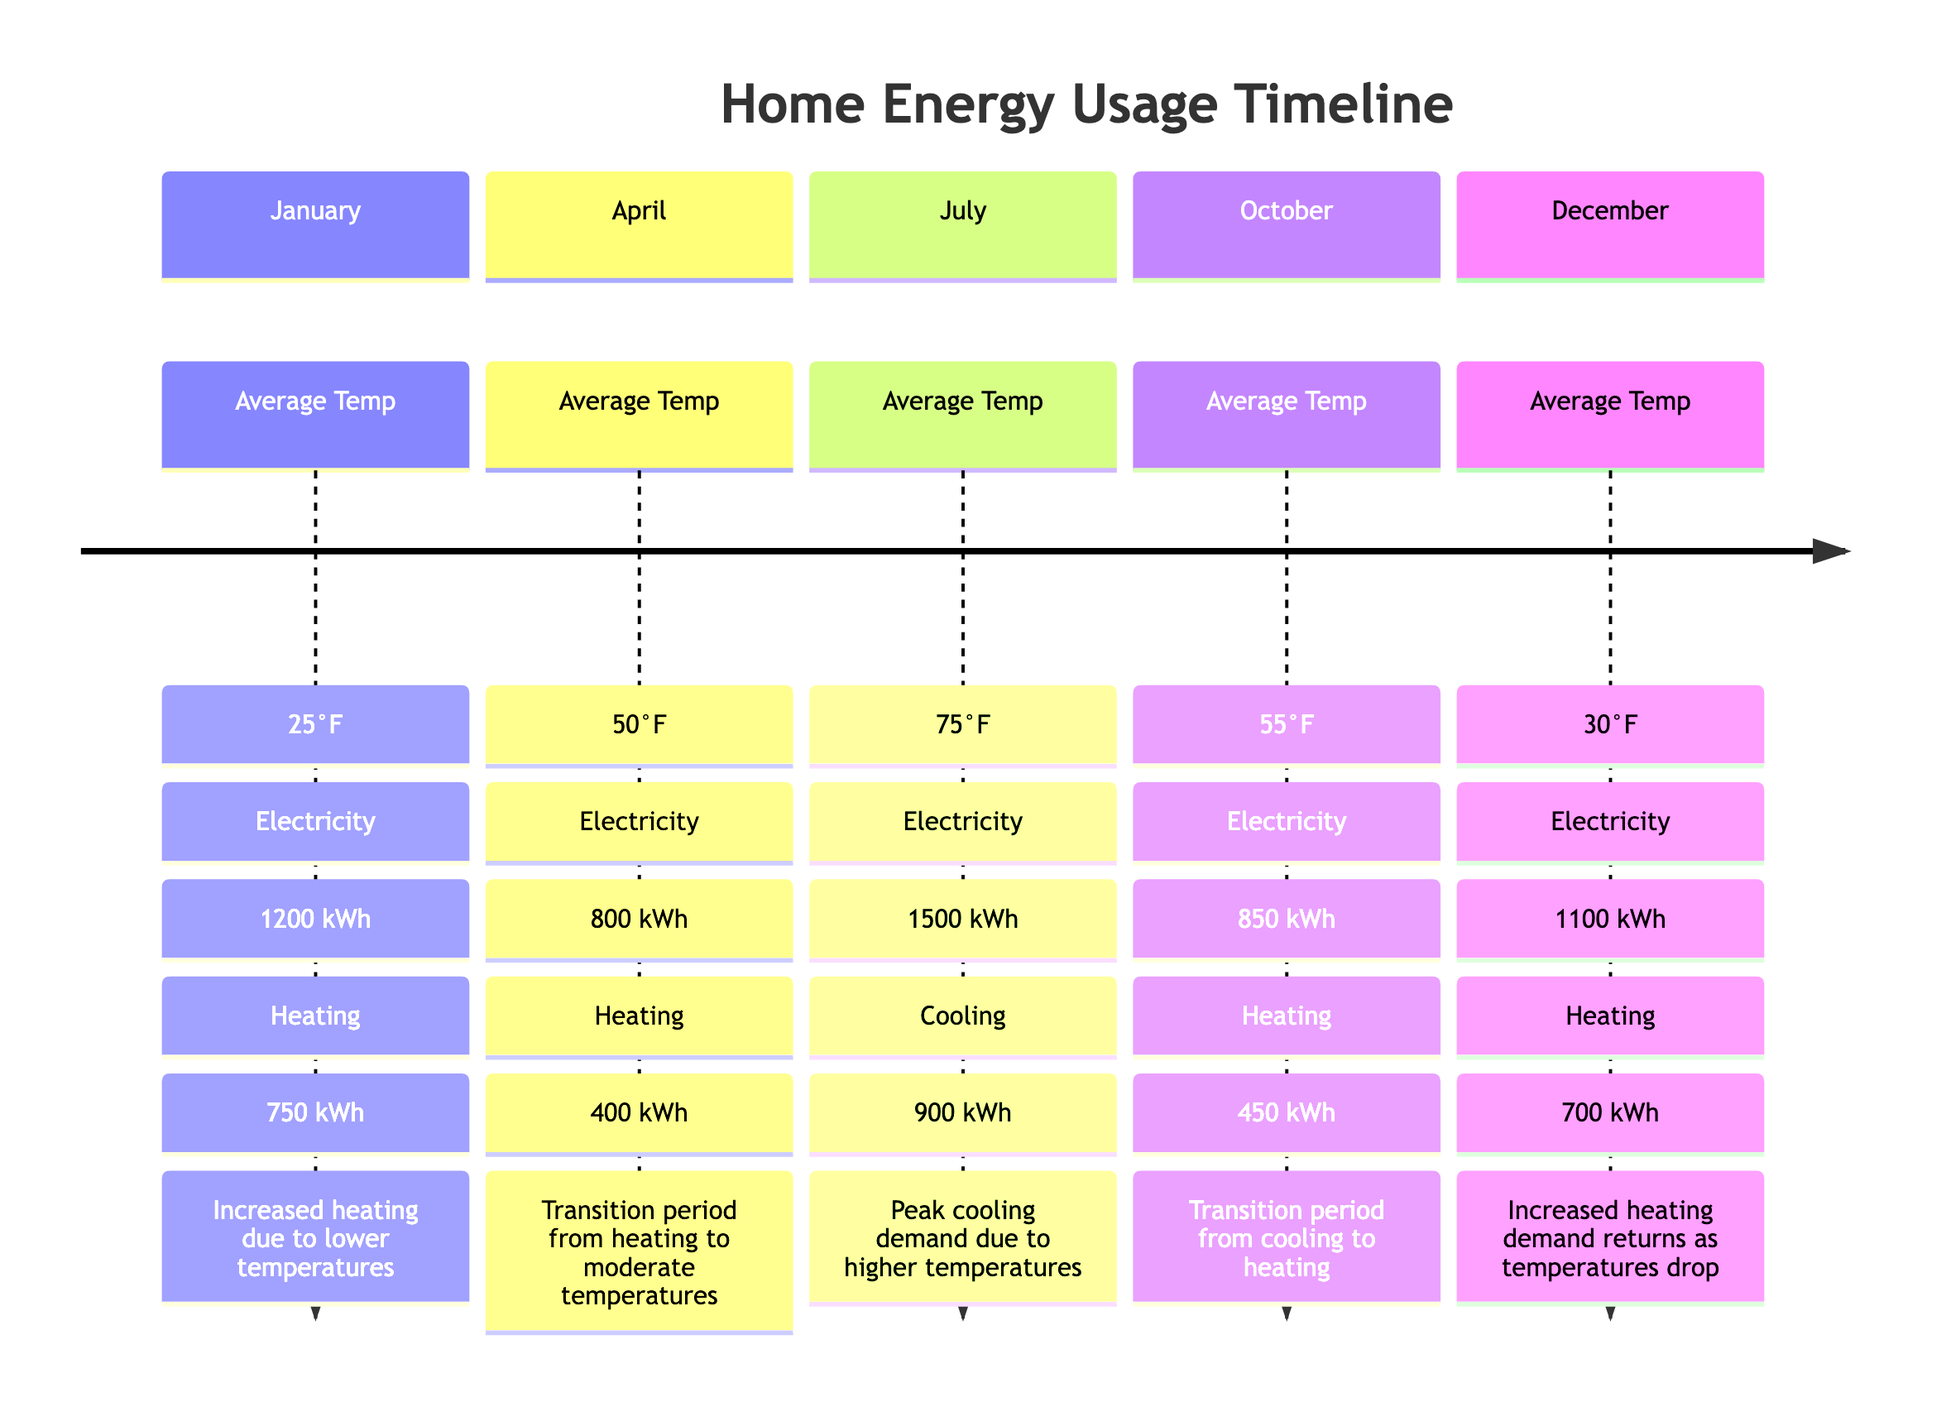What is the electricity consumption in July? The diagram shows that in July, the electricity consumption is represented as 1500 kWh under the monthly section labeled "July."
Answer: 1500 kWh What month has the highest heating consumption? By examining the heating consumption data, January shows the highest value, which is 750 kWh, compared to other months.
Answer: January What is the average temperature in October? The diagram indicates that the average temperature for the month of October is specifically noted as 55°F in its respective section.
Answer: 55°F How much is the cooling consumption in July? The diagram specifies that July has a cooling consumption of 900 kWh directly listed under that month's section.
Answer: 900 kWh Which month sees a transition from heating to cooling? The transition from heating to cooling occurs in October, as indicated by the notes that mention it's a transition period from cooling to heating.
Answer: October What is the average temperature in January? For January, the diagram indicates that the average temperature is listed as 25°F within the section dedicated to that month.
Answer: 25°F What is the total electricity consumption for the year in the months provided? To find the total, we sum the monthly electricity consumption values: January (1200 kWh) + April (800 kWh) + July (1500 kWh) + October (850 kWh) + December (1100 kWh) = 4450 kWh.
Answer: 4450 kWh What is the heating consumption in December? In December, the diagram specifies that the heating consumption is 700 kWh, which is directly noted in that month's section.
Answer: 700 kWh What are the notes for the month of April? The notes for April state that it is a "Transition period from heating to moderate temperatures," which is directly provided under that month.
Answer: Transition period from heating to moderate temperatures 